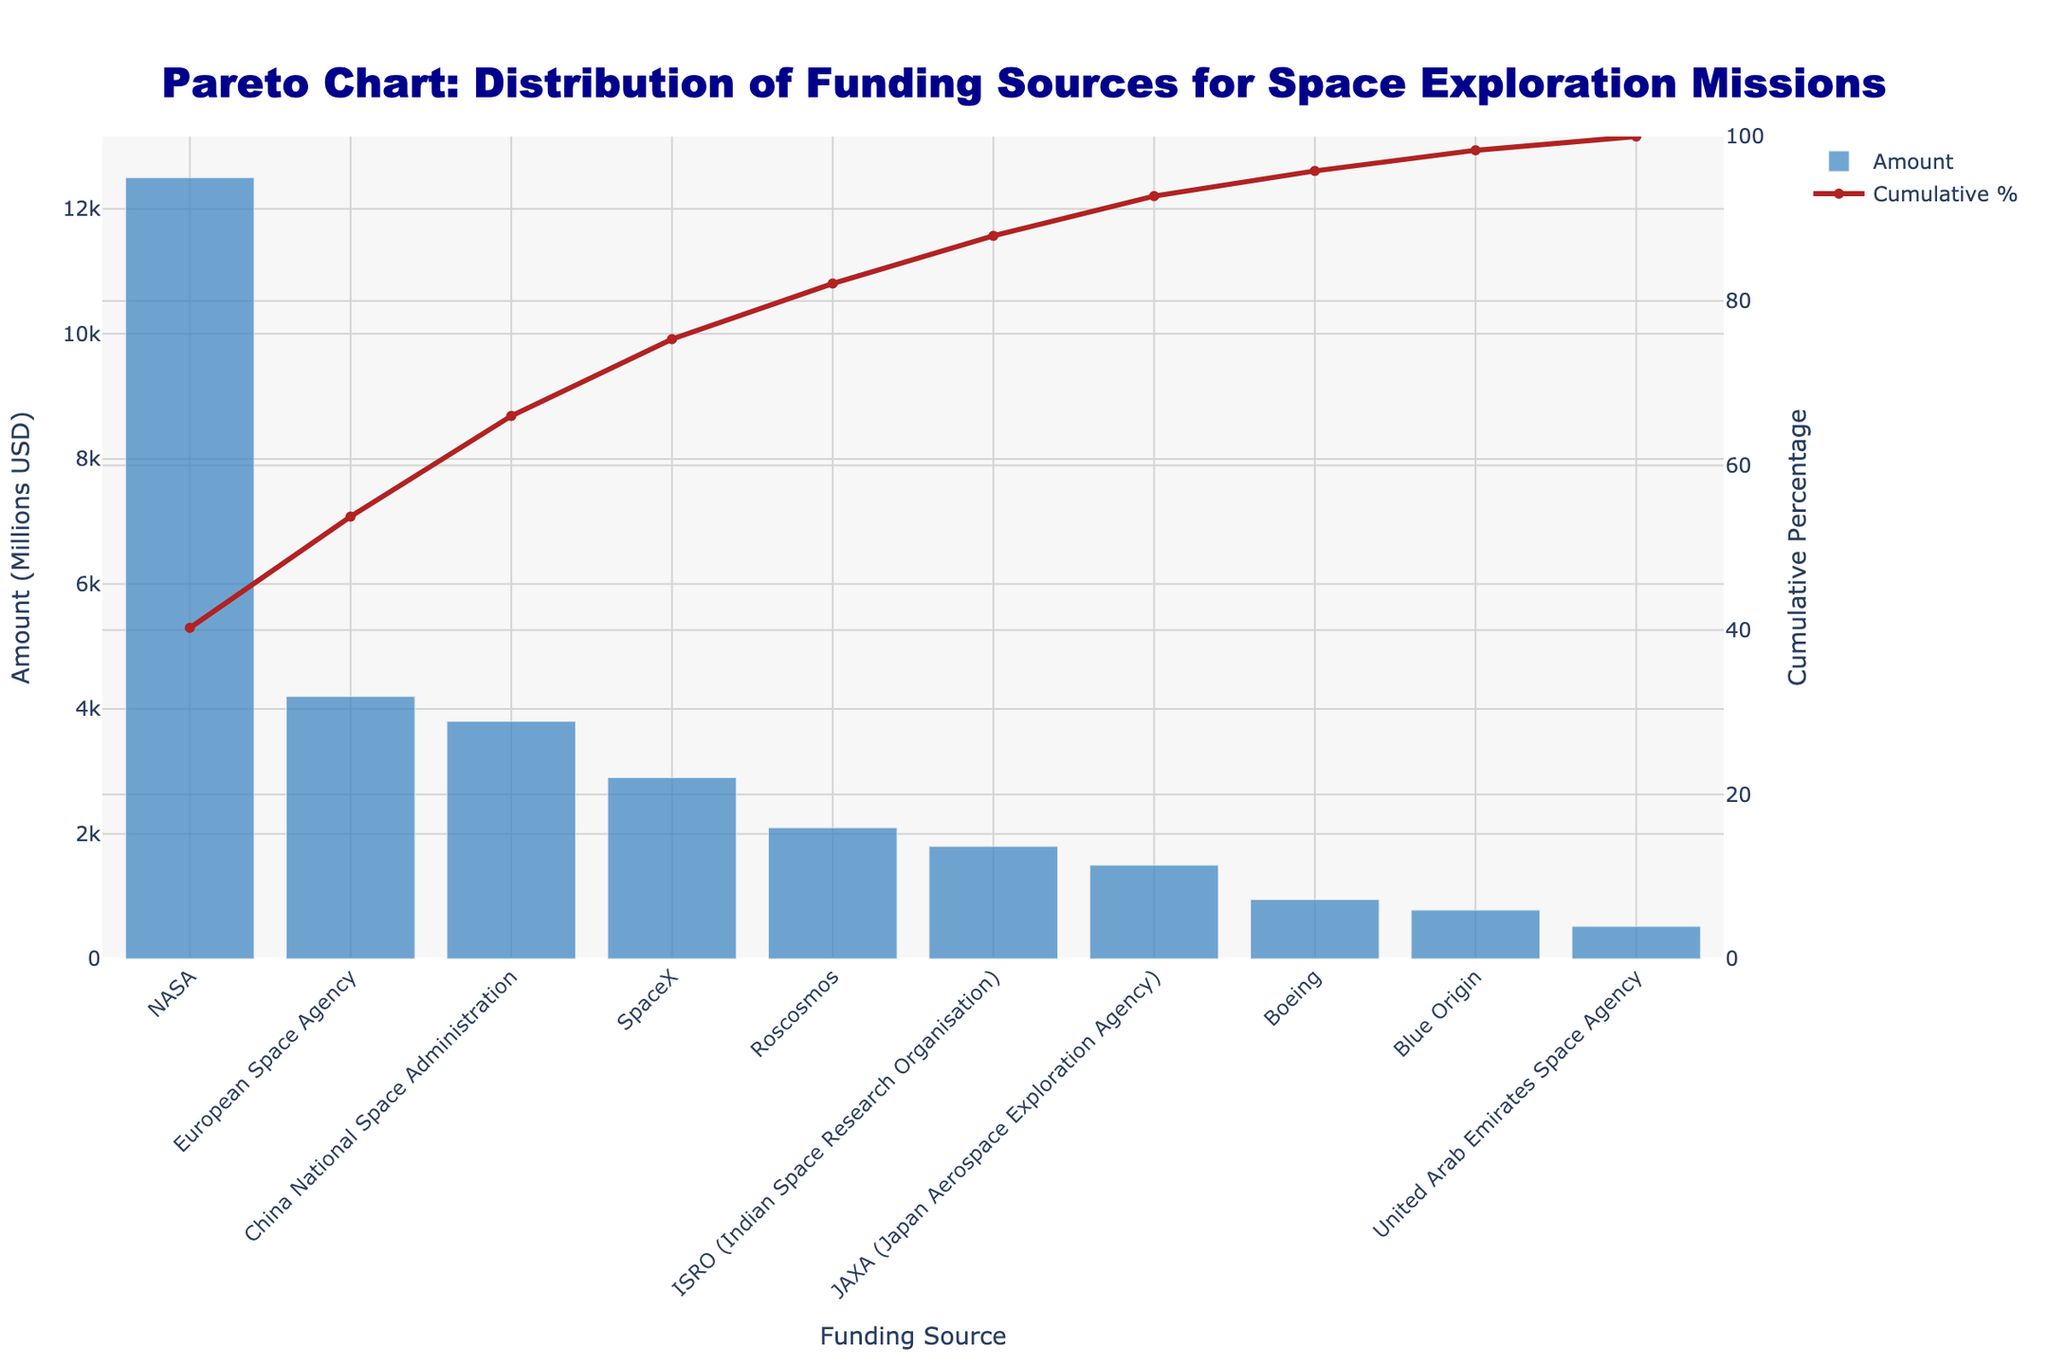What is the title of the figure? The title can be found at the top of the figure. It is usually in a larger and bold font.
Answer: Pareto Chart: Distribution of Funding Sources for Space Exploration Missions What are the top three funding sources based on the amount provided? The top three sources can be identified by looking at the bars in descending order of height, starting from the left of the chart.
Answer: NASA, European Space Agency, China National Space Administration What is the cumulative percentage after including SpaceX in the funding sources? The cumulative percentage can be found by following the red line to the point above SpaceX and looking at the y2-axis on the right.
Answer: About 86.8% Which funding source provided the least amount? The funding source with the smallest bar represents the least amount provided.
Answer: United Arab Emirates Space Agency What is the combined amount of funding provided by NASA and the European Space Agency? The amounts can be read directly from the heights of the bars. NASA provides 12,500 million USD and ESA provides 4,200 million USD. Adding these gives 12,500 + 4,200.
Answer: 16,700 million USD How much more funding did NASA provide compared to SpaceX? Subtract the amount provided by SpaceX from that provided by NASA. NASA provided 12,500 million USD and SpaceX provided 2,900 million USD.
Answer: 9,600 million USD Which funding sources together make up about 75% of the cumulative percentage? Trace the red cumulative percentage line to around the 75% mark on the y2-axis, then find the corresponding funding sources.
Answer: NASA, European Space Agency, China National Space Administration What is the cumulative percentage represented by ISRO? Follow the cumulative percentage line to the ISRO point and check the y2-axis on the right.
Answer: About 94.3% How does the amount provided by Blue Origin compare to Boeing? Look at the heights of the bars for Blue Origin and Boeing and compare their values. Boeing provided 950 million USD whereas Blue Origin provided 780 million USD.
Answer: Boeing provided more Out of the funding sources listed, how many provided more than 2000 million USD? Identify bars that are higher than the 2,000 million USD mark on the y1-axis and count them.
Answer: Four 